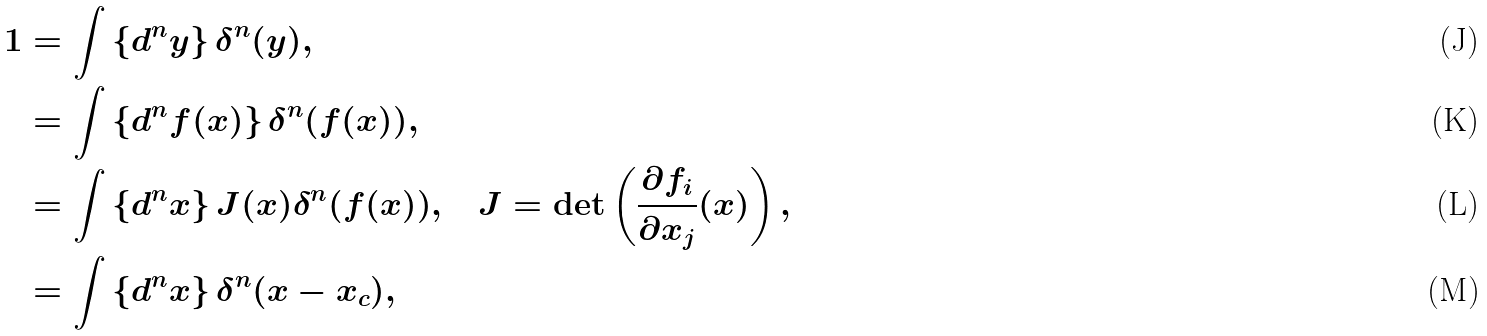<formula> <loc_0><loc_0><loc_500><loc_500>1 & = \int \left \{ d ^ { n } y \right \} \delta ^ { n } ( y ) , \\ & = \int \left \{ d ^ { n } f ( x ) \right \} \delta ^ { n } ( f ( x ) ) , \\ & = \int \left \{ d ^ { n } x \right \} J ( x ) \delta ^ { n } ( f ( x ) ) , \quad J = \det \left ( \frac { \partial f _ { i } } { \partial x _ { j } } ( x ) \right ) , \\ & = \int \left \{ d ^ { n } x \right \} \delta ^ { n } ( x - x _ { c } ) ,</formula> 